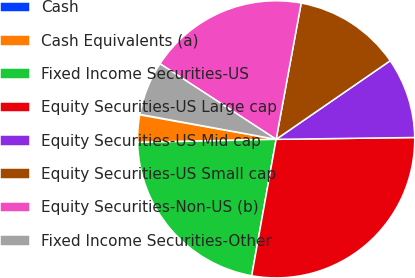Convert chart. <chart><loc_0><loc_0><loc_500><loc_500><pie_chart><fcel>Cash<fcel>Cash Equivalents (a)<fcel>Fixed Income Securities-US<fcel>Equity Securities-US Large cap<fcel>Equity Securities-US Mid cap<fcel>Equity Securities-US Small cap<fcel>Equity Securities-Non-US (b)<fcel>Fixed Income Securities-Other<nl><fcel>0.07%<fcel>3.18%<fcel>21.82%<fcel>28.03%<fcel>9.39%<fcel>12.5%<fcel>18.71%<fcel>6.29%<nl></chart> 